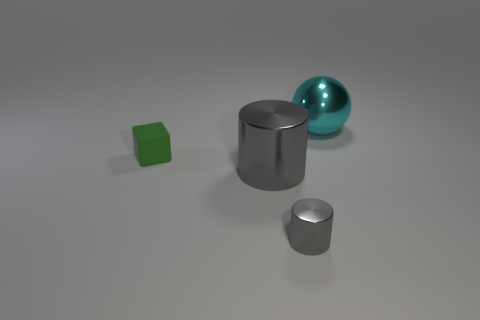Does the large cylinder have the same color as the small cylinder?
Ensure brevity in your answer.  Yes. What number of other things are made of the same material as the tiny block?
Offer a very short reply. 0. What number of green blocks are in front of the gray cylinder that is behind the small gray cylinder?
Give a very brief answer. 0. Are there any other things that have the same shape as the green thing?
Give a very brief answer. No. There is a tiny object that is right of the rubber cube; is its color the same as the metal object that is on the left side of the small cylinder?
Offer a very short reply. Yes. Is the number of cyan things less than the number of small purple metallic things?
Provide a succinct answer. No. What shape is the tiny object that is on the left side of the big object that is to the left of the big cyan metal sphere?
Ensure brevity in your answer.  Cube. There is a big metal thing that is in front of the small object that is behind the big thing left of the tiny cylinder; what is its shape?
Offer a terse response. Cylinder. How many objects are either large shiny objects in front of the small green rubber object or gray cylinders behind the tiny gray thing?
Ensure brevity in your answer.  1. There is a green thing; does it have the same size as the cylinder that is in front of the big cylinder?
Your response must be concise. Yes. 